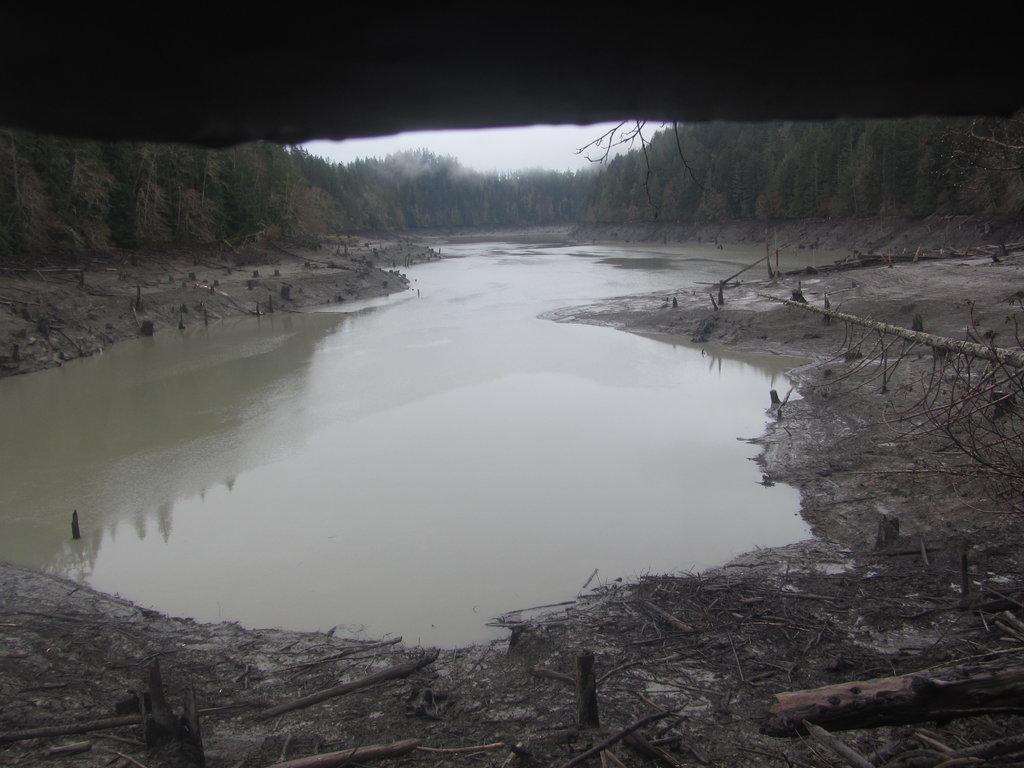Can you describe this image briefly? At the bottom of this image, there are sticks and wooden pieces on the wet ground. Beside them, there is water. On both sides of this water, there are trees. In the background, there are trees and there is sky. 